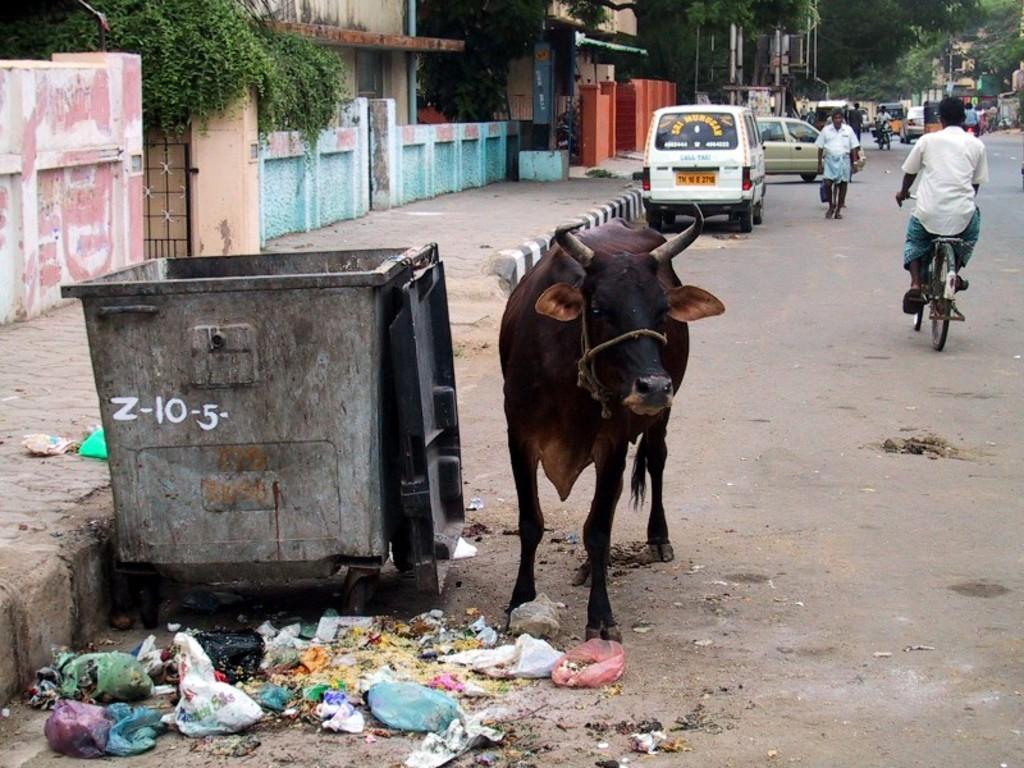Describe this image in one or two sentences. This picture we see a cow near a dustbin and we see few cars parked and man riding a bicycle and a man walking on the road and we see a house and we see some trees 